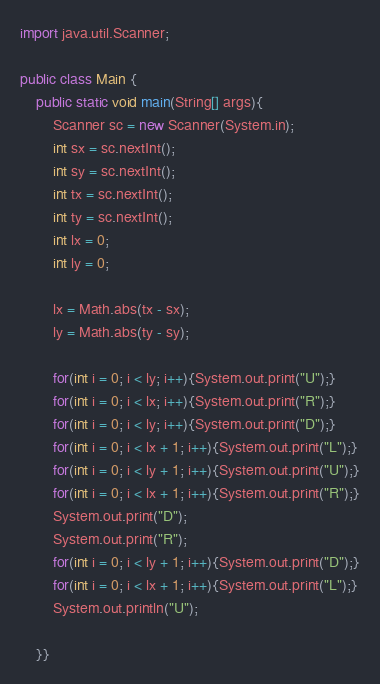<code> <loc_0><loc_0><loc_500><loc_500><_Java_>import java.util.Scanner;

public class Main {
	public static void main(String[] args){
		Scanner sc = new Scanner(System.in);
		int sx = sc.nextInt();
		int sy = sc.nextInt();
		int tx = sc.nextInt();
		int ty = sc.nextInt();
		int lx = 0;
		int ly = 0;
		
		lx = Math.abs(tx - sx);
		ly = Math.abs(ty - sy);
		
		for(int i = 0; i < ly; i++){System.out.print("U");}
		for(int i = 0; i < lx; i++){System.out.print("R");}
		for(int i = 0; i < ly; i++){System.out.print("D");}
		for(int i = 0; i < lx + 1; i++){System.out.print("L");}
		for(int i = 0; i < ly + 1; i++){System.out.print("U");}
		for(int i = 0; i < lx + 1; i++){System.out.print("R");}
		System.out.print("D");
		System.out.print("R");
		for(int i = 0; i < ly + 1; i++){System.out.print("D");}
		for(int i = 0; i < lx + 1; i++){System.out.print("L");}
		System.out.println("U");
		
	}}</code> 